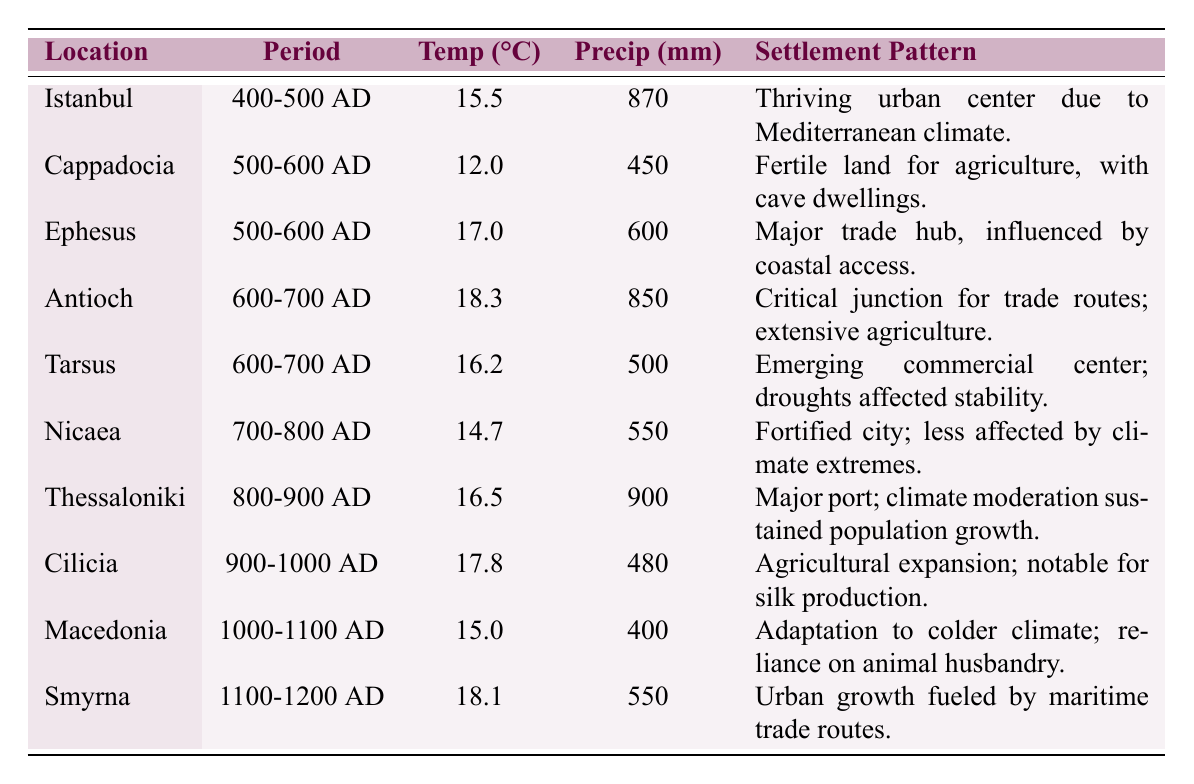What was the average temperature in Ephesus during 500-600 AD? The table lists the average temperature for Ephesus during 500-600 AD as 17.0°C.
Answer: 17.0°C Which location had the highest precipitation recorded, and what was that amount? Thessaloniki had the highest precipitation recorded at 900 mm, according to the table.
Answer: 900 mm Was Istanbul's settlement pattern influenced by its climate? Yes, the settlement pattern in Istanbul reflects a thriving urban center due to its Mediterranean climate.
Answer: Yes What was the difference in average temperature between Antioch (600-700 AD) and Macedonia (1000-1100 AD)? The average temperature in Antioch during 600-700 AD was 18.3°C and in Macedonia during 1000-1100 AD it was 15.0°C. The difference is 18.3 - 15.0 = 3.3°C.
Answer: 3.3°C Did Cappadocia experience a higher temperature than Tarsus in the 600-700 AD period? Tarsus is in the 600-700 AD period with an average temperature of 16.2°C, while Cappadocia is in the 500-600 AD period with an average temperature of 12.0°C. Thus, Tarsus had a higher temperature.
Answer: Yes What is the average precipitation from the locations listed for the 700-800 AD time period? The only location in the 700-800 AD period is Nicaea with 550 mm of precipitation. Therefore, the average is 550 mm.
Answer: 550 mm In which time period did Cilicia have an average temperature greater than 17°C? Cilicia had an average temperature of 17.8°C in the 900-1000 AD period, which is greater than 17°C.
Answer: 900-1000 AD How many locations recorded a settlement pattern tied to trade routes, and which are they? The table indicates that Ephesus (500-600 AD), Antioch (600-700 AD), Thessaloniki (800-900 AD), and Smyrna (1100-1200 AD) had settlement patterns tied to trade routes. There are four such locations.
Answer: 4 locations (Ephesus, Antioch, Thessaloniki, Smyrna) Which region experienced emerging commercial activity in the 600-700 AD timeframe? Tarsus during the 600-700 AD period is described as an emerging commercial center, influenced by droughts affecting stability.
Answer: Tarsus Was there a notable agricultural expansion in Cilicia in the 900-1000 AD period? Yes, Chalilcia's settlement pattern in the 900-1000 AD period was described as agricultural expansion notable for silk production.
Answer: Yes Calculate the average temperature of the region from 400-500 AD through 1100-1200 AD. Adding the average temperatures: 15.5 (Istanbul) + 12.0 (Cappadocia) + 17.0 (Ephesus) + 18.3 (Antioch) + 16.2 (Tarsus) + 14.7 (Nicaea) + 16.5 (Thessaloniki) + 17.8 (Cilicia) + 15.0 (Macedonia) + 18.1 (Smyrna). The total is 15.5 + 12.0 + 17.0 + 18.3 + 16.2 + 14.7 + 16.5 + 17.8 + 15.0 + 18.1 =  14.8°C. There are 10 locations, so the average is 159.6 / 10 = 15.96°C.
Answer: 15.96°C 